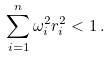Convert formula to latex. <formula><loc_0><loc_0><loc_500><loc_500>\sum _ { i = 1 } ^ { n } \omega _ { i } ^ { 2 } r _ { i } ^ { 2 } < 1 \, .</formula> 